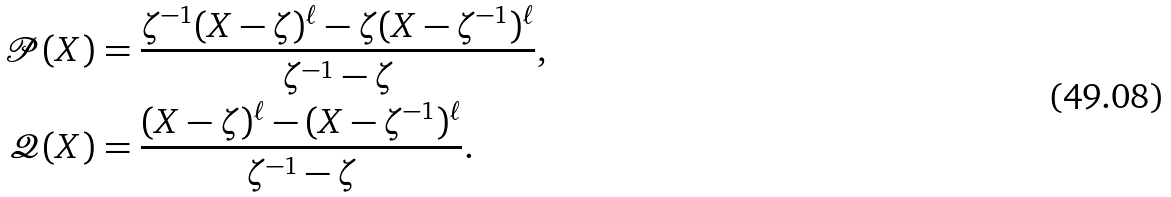Convert formula to latex. <formula><loc_0><loc_0><loc_500><loc_500>\mathcal { P } ( X ) & = \frac { \zeta ^ { - 1 } ( X - \zeta ) ^ { \ell } - \zeta ( X - \zeta ^ { - 1 } ) ^ { \ell } } { \zeta ^ { - 1 } - \zeta } , \\ \mathcal { Q } ( X ) & = \frac { ( X - \zeta ) ^ { \ell } - ( X - \zeta ^ { - 1 } ) ^ { \ell } } { \zeta ^ { - 1 } - \zeta } .</formula> 